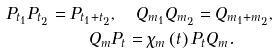Convert formula to latex. <formula><loc_0><loc_0><loc_500><loc_500>P _ { t _ { 1 } } P _ { t _ { 2 } } = P _ { t _ { 1 } + t _ { 2 } } & , \quad Q _ { m _ { 1 } } Q _ { m _ { 2 } } = Q _ { m _ { 1 } + m _ { 2 } } , \\ Q _ { m } & P _ { t } = \chi _ { m } \left ( t \right ) P _ { t } Q _ { m } .</formula> 